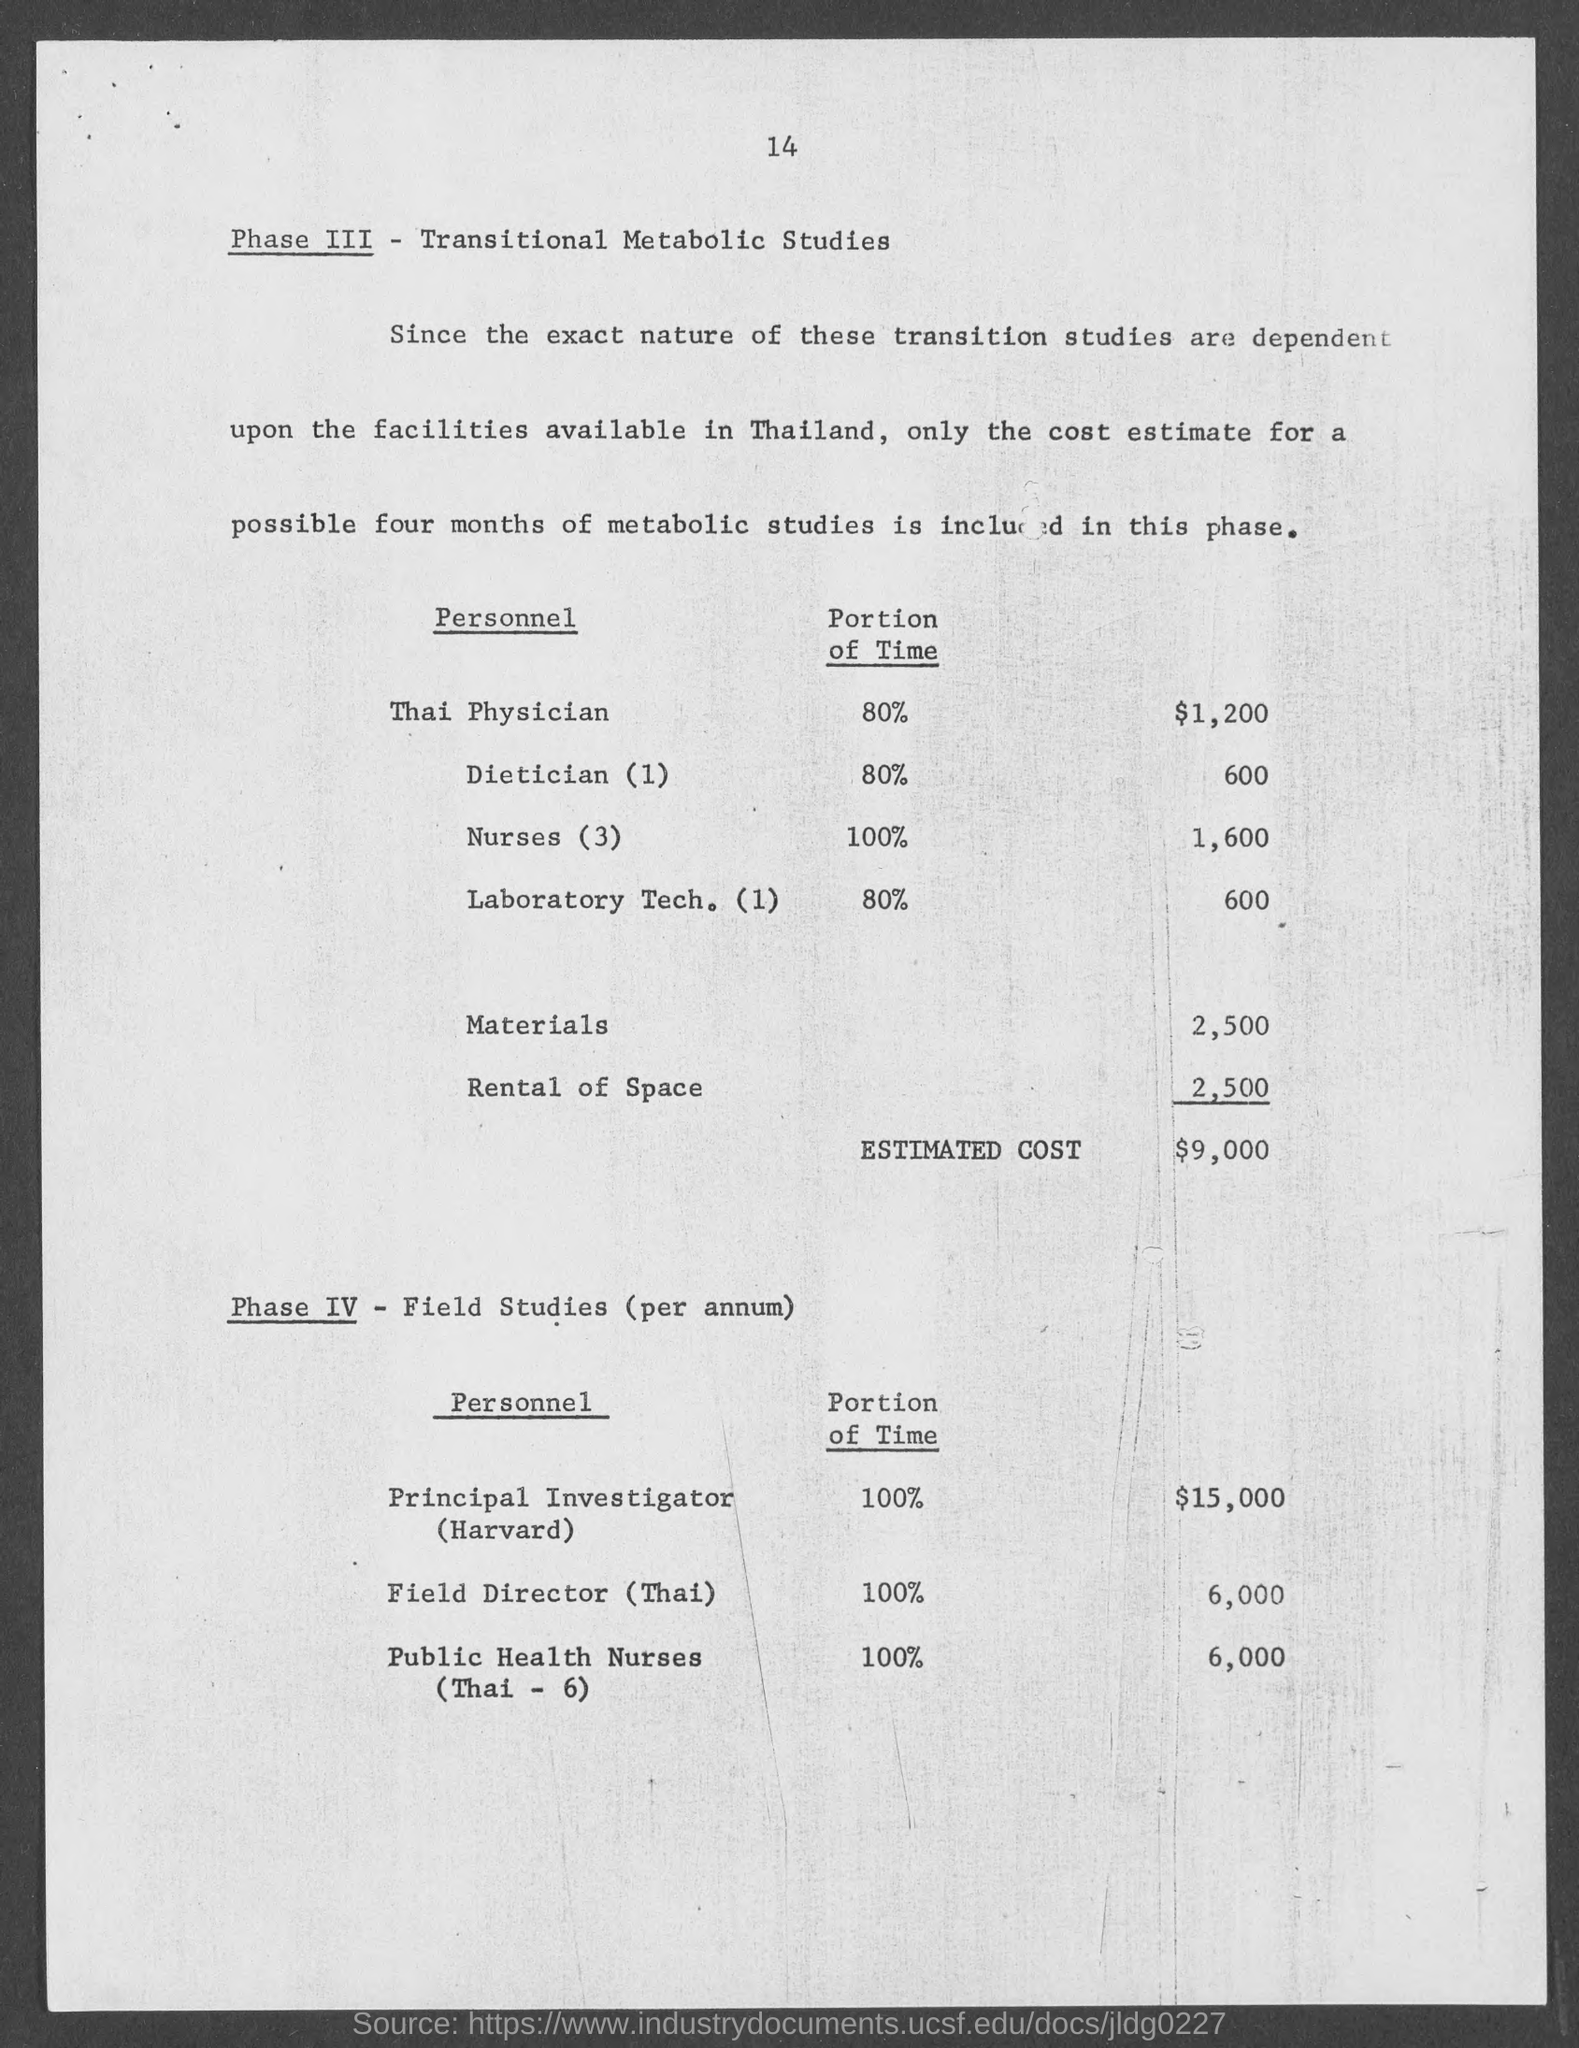What is the cost estimate for Thai Physician given in the document?
Your answer should be very brief. 1,200. What is the cost estimate for Principal Investigator (Harvard) given in the document?
Your answer should be very brief. 15,000. What portion of the time is dedicated by the principal investigator as per the document?
Your answer should be compact. 100%. What portion of the time is dedicated by the Thai Physician as per the document?
Offer a very short reply. 80%. 